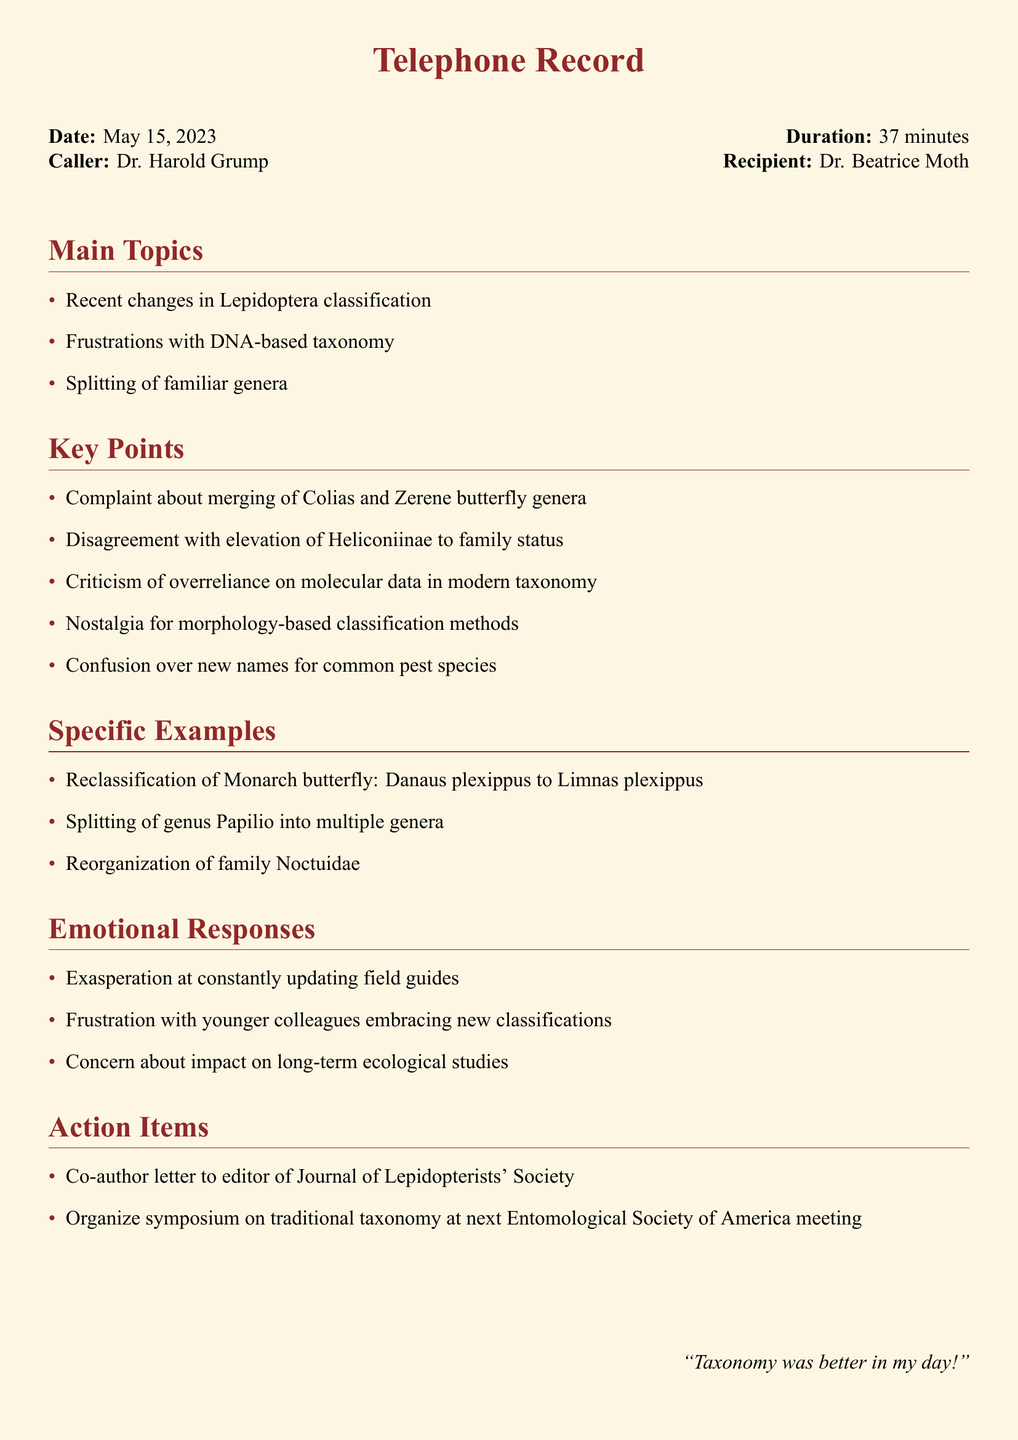What is the date of the call? The date of the call is stated in the document as May 15, 2023.
Answer: May 15, 2023 Who is the caller? The caller is identified as Dr. Harold Grump in the document.
Answer: Dr. Harold Grump What was the duration of the call? The duration of the call is mentioned in the document as 37 minutes.
Answer: 37 minutes What specific example is given regarding reclassification? The document provides the reclassification of Monarch butterfly: Danaus plexippus to Limnas plexippus as an example.
Answer: Danaus plexippus to Limnas plexippus What frustration is mentioned about younger colleagues? The document mentions frustration with younger colleagues embracing new classifications.
Answer: Embracing new classifications What action item involves a letter? The action item noted in the document indicates to co-author a letter to the editor of the Journal of Lepidopterists' Society.
Answer: Letter to editor of Journal of Lepidopterists' Society Which family underwent reorganization? The reorganization mentioned in the document pertains to the family Noctuidae.
Answer: Noctuidae What was a complaint regarding butterfly genera? The document describes a complaint about merging of Colias and Zerene butterfly genera.
Answer: Merging of Colias and Zerene 